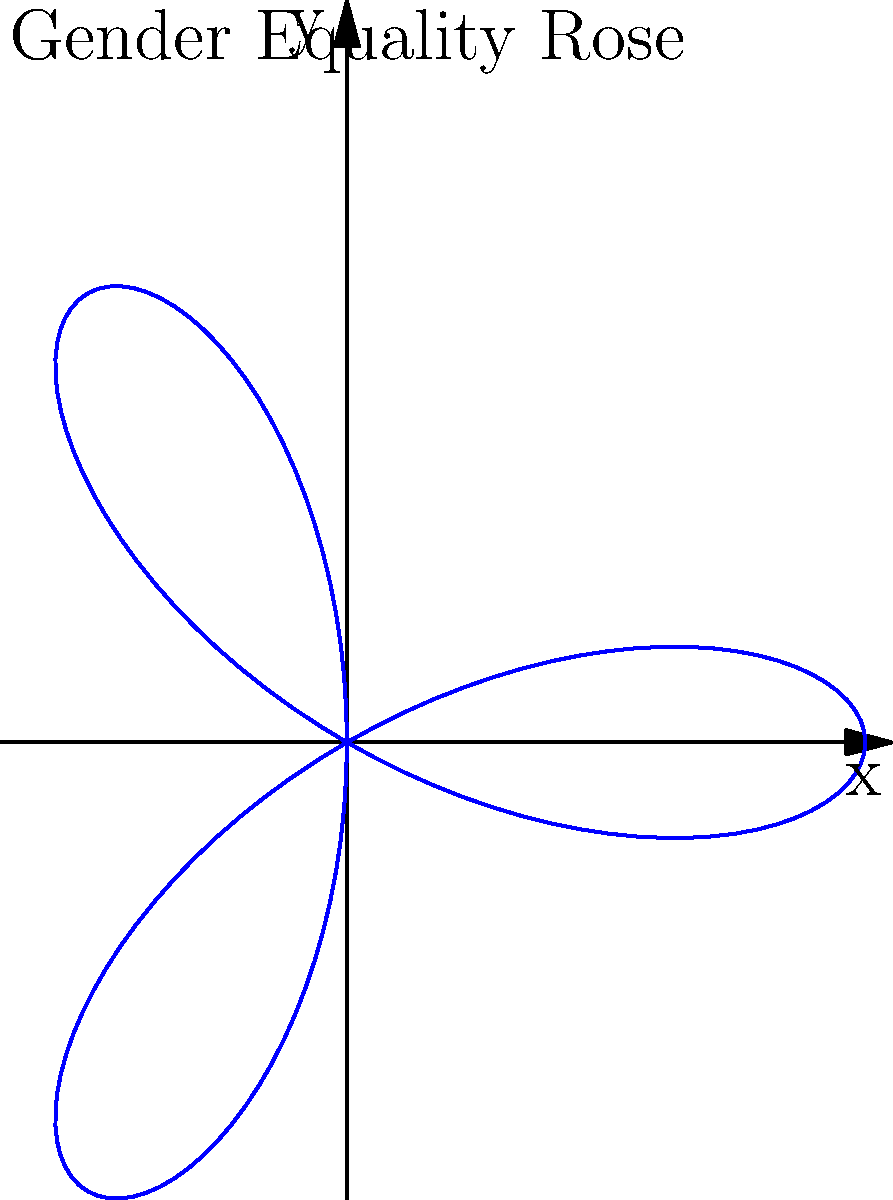A polar rose curve represents gender equality progress, where the area enclosed by the curve symbolizes the level of equality achieved. The curve is given by the equation $r = 2\cos(3\theta)$. Calculate the total area enclosed by this 3-petaled rose curve to determine the overall gender equality score. To find the area enclosed by the polar rose curve, we'll follow these steps:

1) The general formula for the area enclosed by a polar curve is:
   $$A = \frac{1}{2}\int_{0}^{2\pi} r^2(\theta) d\theta$$

2) For our curve, $r = 2\cos(3\theta)$, so $r^2 = 4\cos^2(3\theta)$

3) Substituting this into our area formula:
   $$A = \frac{1}{2}\int_{0}^{2\pi} 4\cos^2(3\theta) d\theta$$

4) Using the trigonometric identity $\cos^2(x) = \frac{1}{2}(1 + \cos(2x))$:
   $$A = \frac{1}{2}\int_{0}^{2\pi} 4 \cdot \frac{1}{2}(1 + \cos(6\theta)) d\theta$$
   $$A = \int_{0}^{2\pi} (1 + \cos(6\theta)) d\theta$$

5) Integrating:
   $$A = [\theta + \frac{1}{6}\sin(6\theta)]_0^{2\pi}$$

6) Evaluating the integral:
   $$A = (2\pi + 0) - (0 + 0) = 2\pi$$

Therefore, the total area enclosed by the curve is $2\pi$ square units.
Answer: $2\pi$ square units 